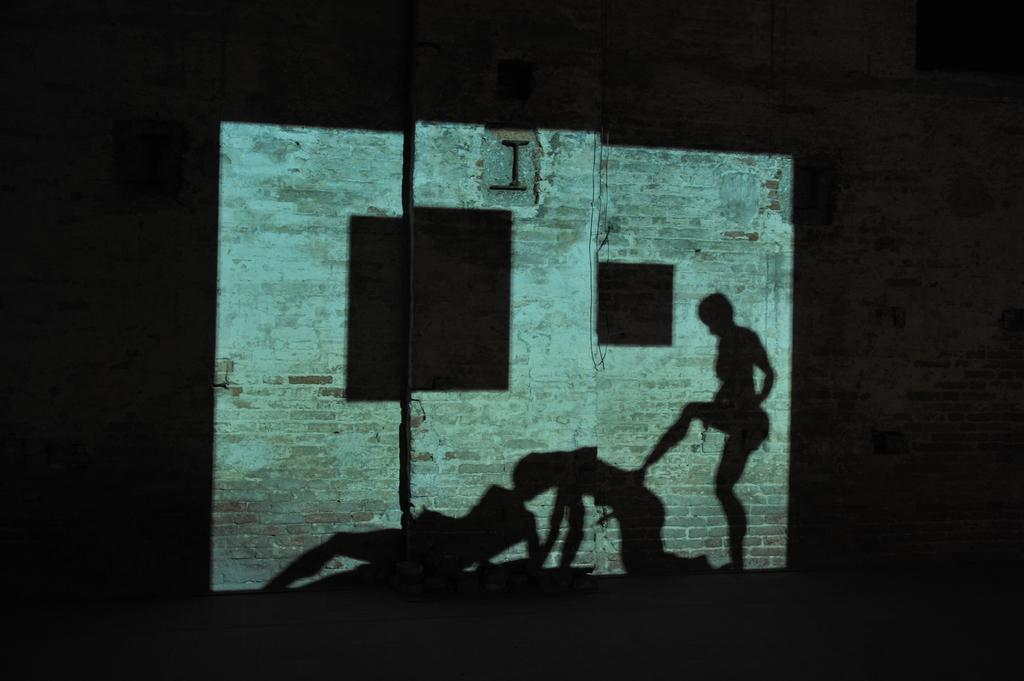What is the main object in the center of the image? There is a screen in the center of the image. What can be seen on the screen? The screen has reflections of people. What is visible in the background of the image? There is a wall in the background of the image. How many kittens can be seen biting the wall in the image? There are no kittens present in the image, and they are not interacting with the wall. 